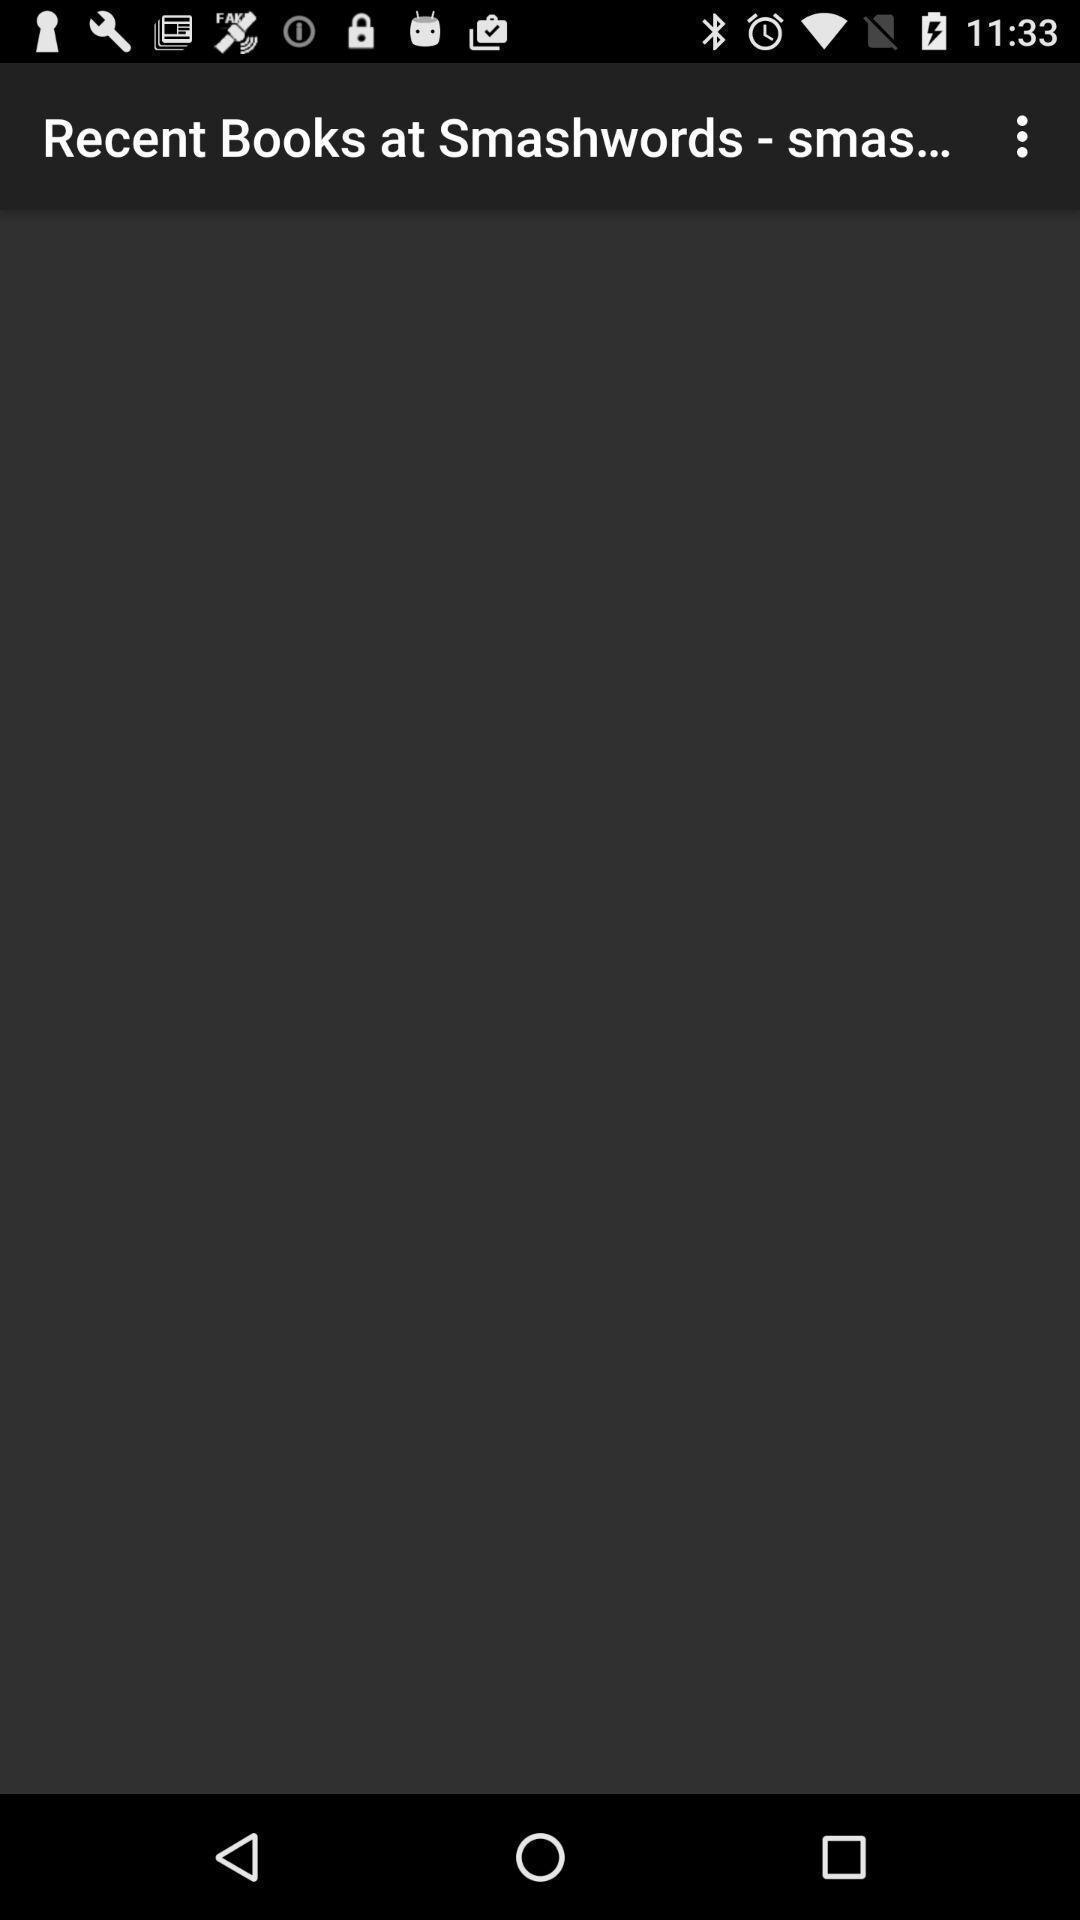Provide a textual representation of this image. Search of a book in a book reading app. 